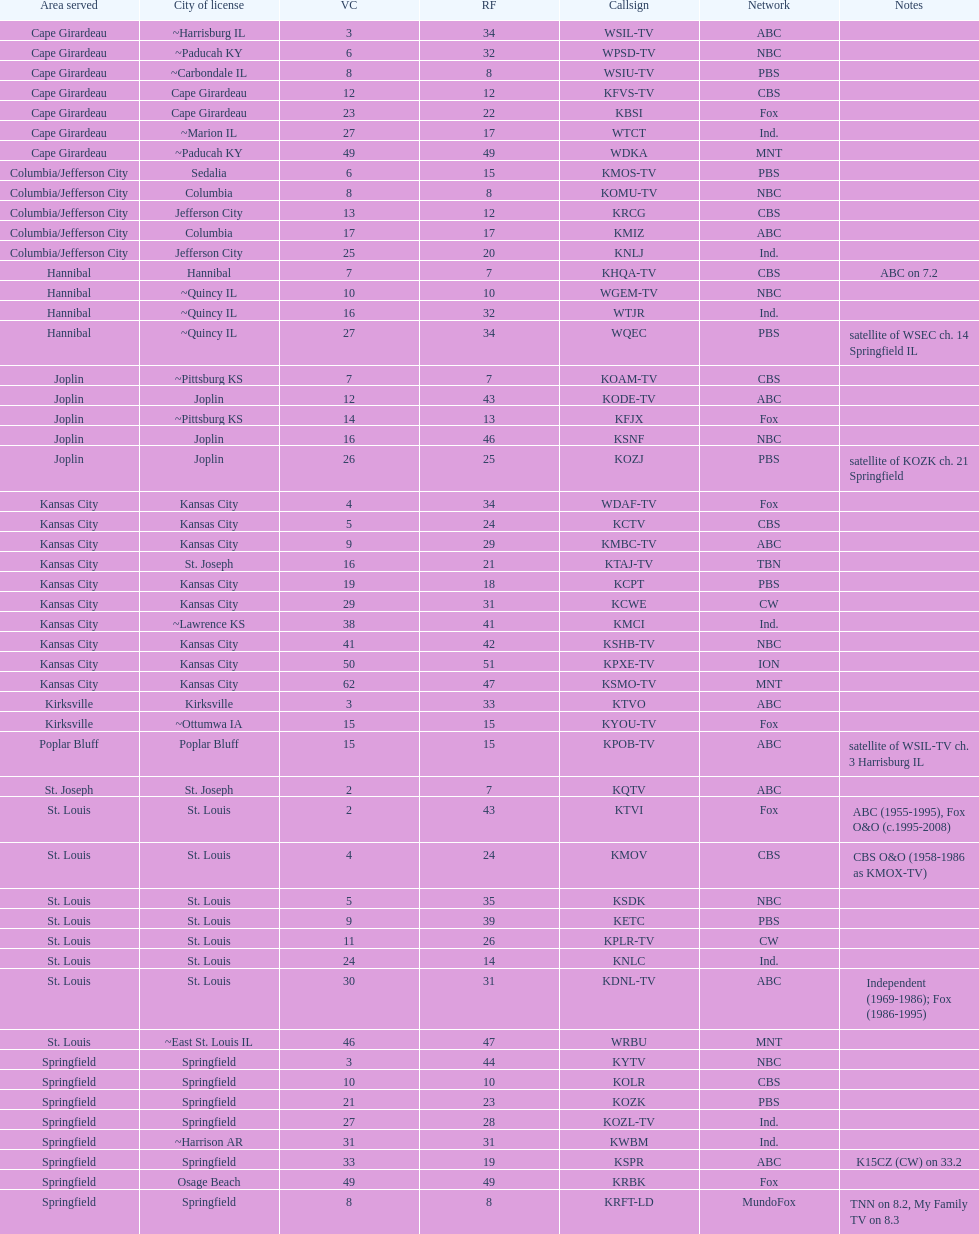What is the count of participants on the cbs network? 7. 